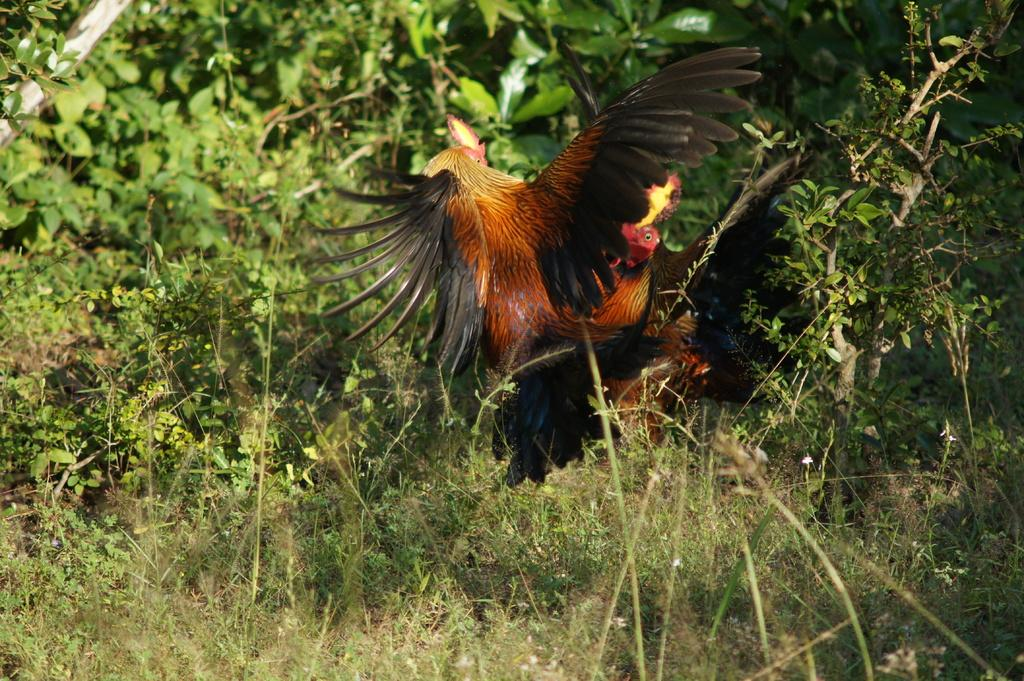How many hens are present in the image? There are two hens in the image. What can be seen in the background of the image? There are trees in the background of the image. What type of vegetation is at the bottom of the image? There is grass at the bottom of the image. What type of cream can be seen on the boat in the image? There is no boat or cream present in the image; it features two hens and a grassy area with trees in the background. 